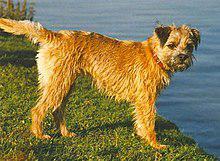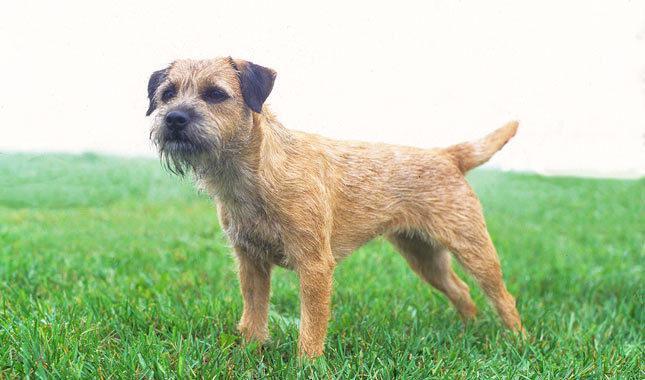The first image is the image on the left, the second image is the image on the right. Assess this claim about the two images: "The dog on each image is facing the opposite direction of where the other is facing.". Correct or not? Answer yes or no. Yes. 